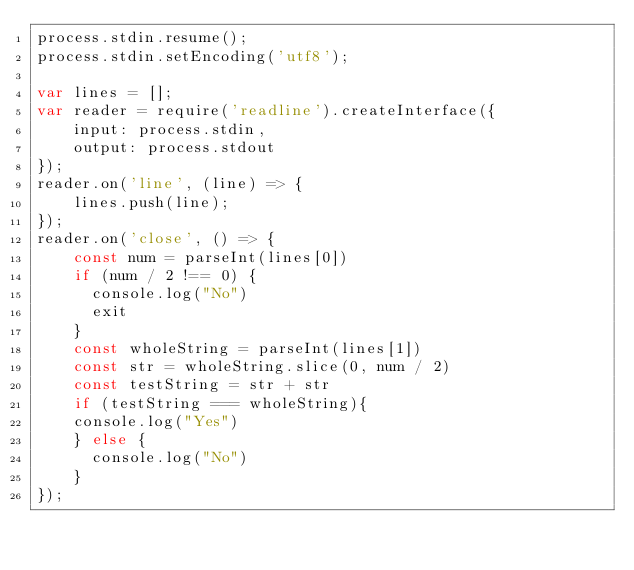Convert code to text. <code><loc_0><loc_0><loc_500><loc_500><_JavaScript_>process.stdin.resume();
process.stdin.setEncoding('utf8');

var lines = [];
var reader = require('readline').createInterface({
    input: process.stdin,
    output: process.stdout
});
reader.on('line', (line) => {
    lines.push(line);
});
reader.on('close', () => {
    const num = parseInt(lines[0])
    if (num / 2 !== 0) {
      console.log("No")
      exit
    }
    const wholeString = parseInt(lines[1])
    const str = wholeString.slice(0, num / 2)
    const testString = str + str
    if (testString === wholeString){
		console.log("Yes")
    } else {
      console.log("No")
    }
});</code> 